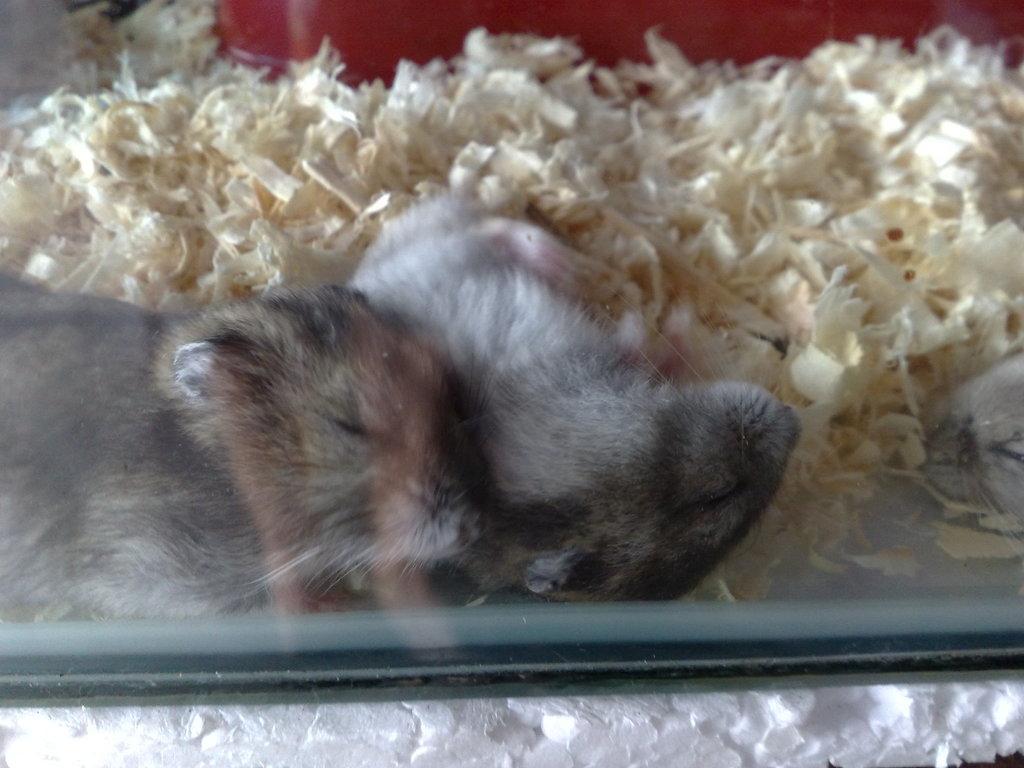Could you give a brief overview of what you see in this image? In this picture there is a thermocol at the bottom side of the image and there is a glass in the center of the image, there is a cat inside the glass, it seems to be some items behind the cat. 